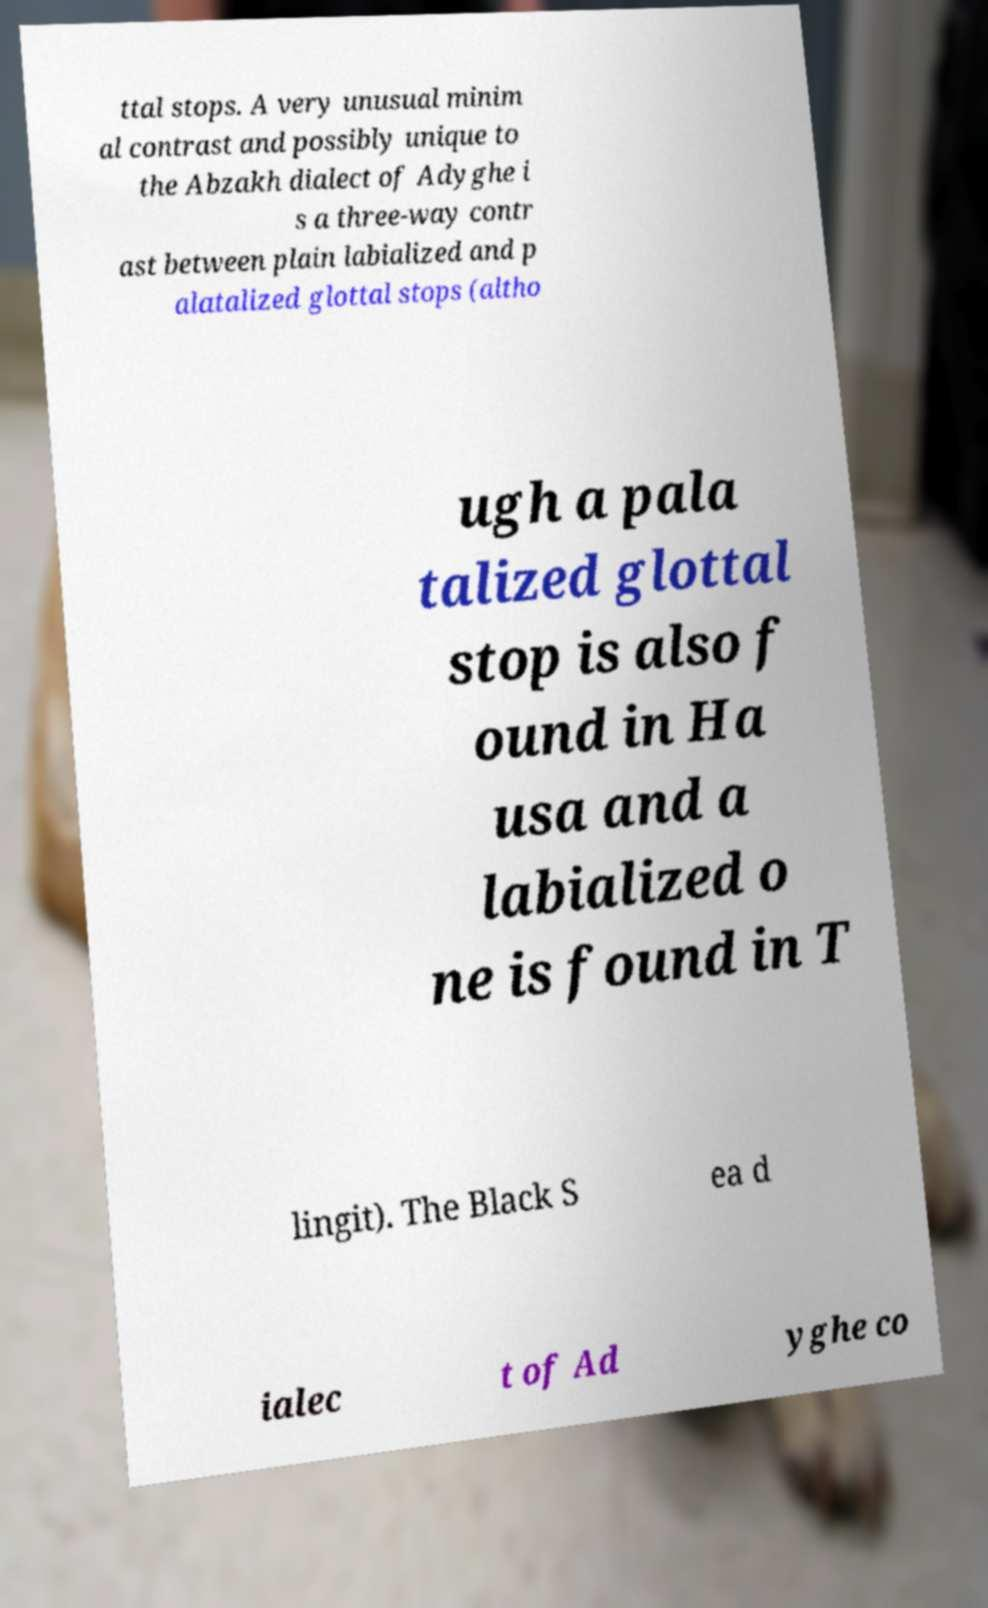Can you read and provide the text displayed in the image?This photo seems to have some interesting text. Can you extract and type it out for me? ttal stops. A very unusual minim al contrast and possibly unique to the Abzakh dialect of Adyghe i s a three-way contr ast between plain labialized and p alatalized glottal stops (altho ugh a pala talized glottal stop is also f ound in Ha usa and a labialized o ne is found in T lingit). The Black S ea d ialec t of Ad yghe co 